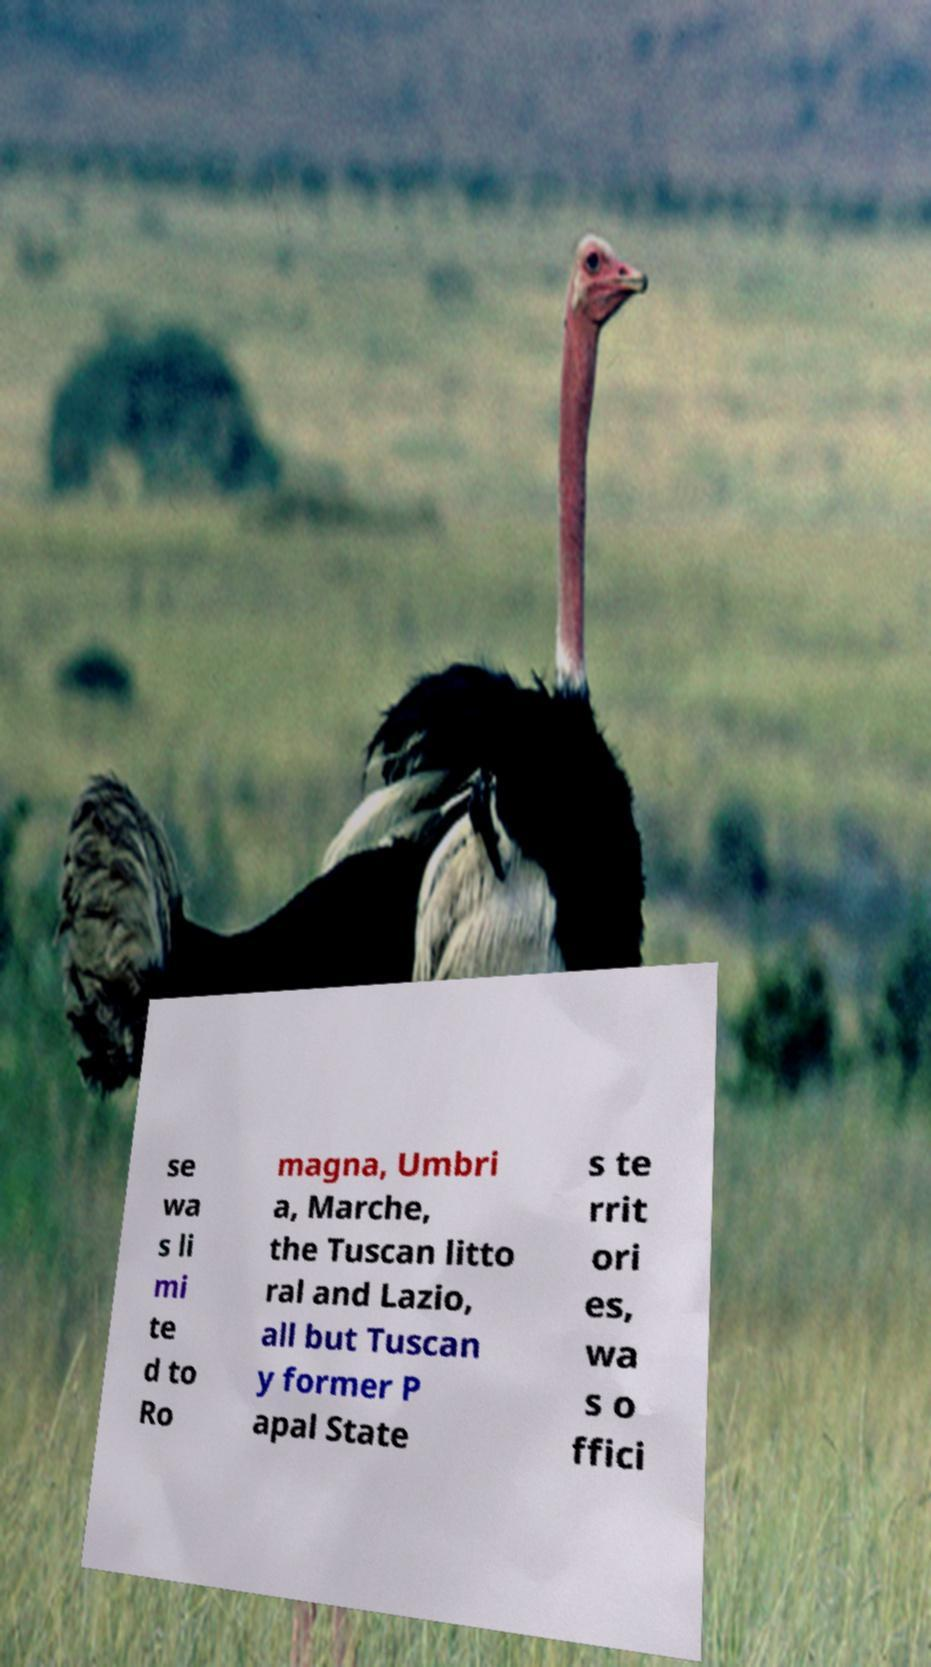Please read and relay the text visible in this image. What does it say? se wa s li mi te d to Ro magna, Umbri a, Marche, the Tuscan litto ral and Lazio, all but Tuscan y former P apal State s te rrit ori es, wa s o ffici 